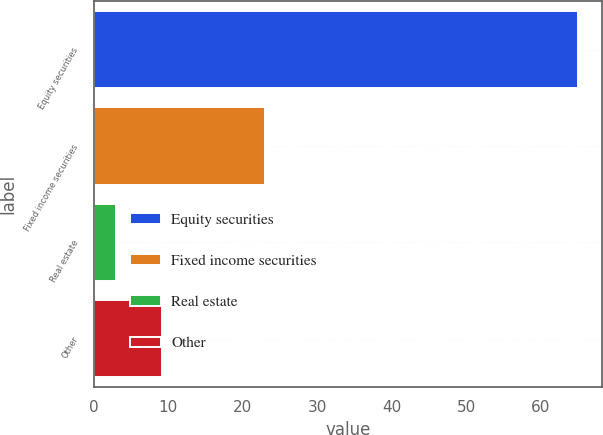<chart> <loc_0><loc_0><loc_500><loc_500><bar_chart><fcel>Equity securities<fcel>Fixed income securities<fcel>Real estate<fcel>Other<nl><fcel>65<fcel>23<fcel>3<fcel>9.2<nl></chart> 